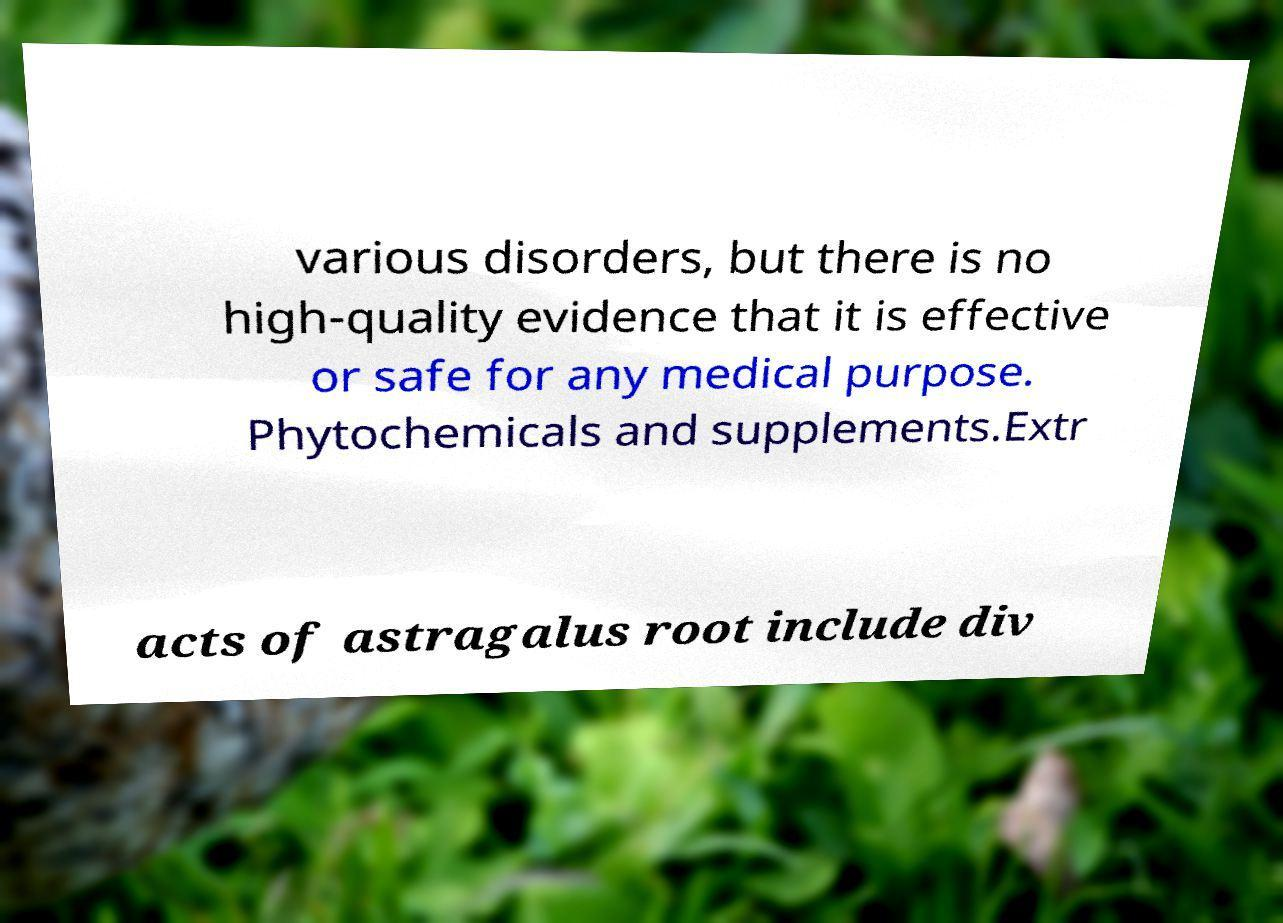For documentation purposes, I need the text within this image transcribed. Could you provide that? various disorders, but there is no high-quality evidence that it is effective or safe for any medical purpose. Phytochemicals and supplements.Extr acts of astragalus root include div 